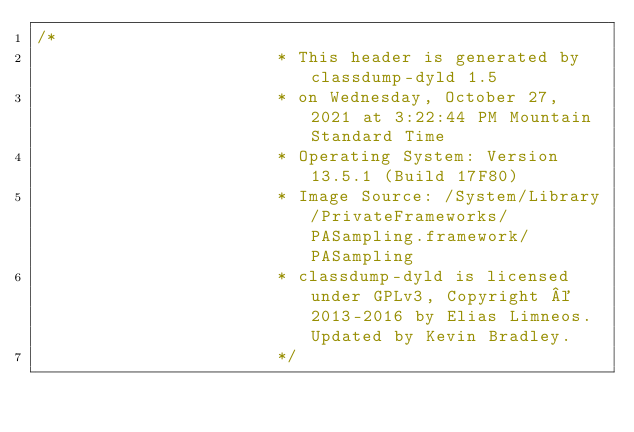Convert code to text. <code><loc_0><loc_0><loc_500><loc_500><_C_>/*
                       * This header is generated by classdump-dyld 1.5
                       * on Wednesday, October 27, 2021 at 3:22:44 PM Mountain Standard Time
                       * Operating System: Version 13.5.1 (Build 17F80)
                       * Image Source: /System/Library/PrivateFrameworks/PASampling.framework/PASampling
                       * classdump-dyld is licensed under GPLv3, Copyright © 2013-2016 by Elias Limneos. Updated by Kevin Bradley.
                       */

</code> 